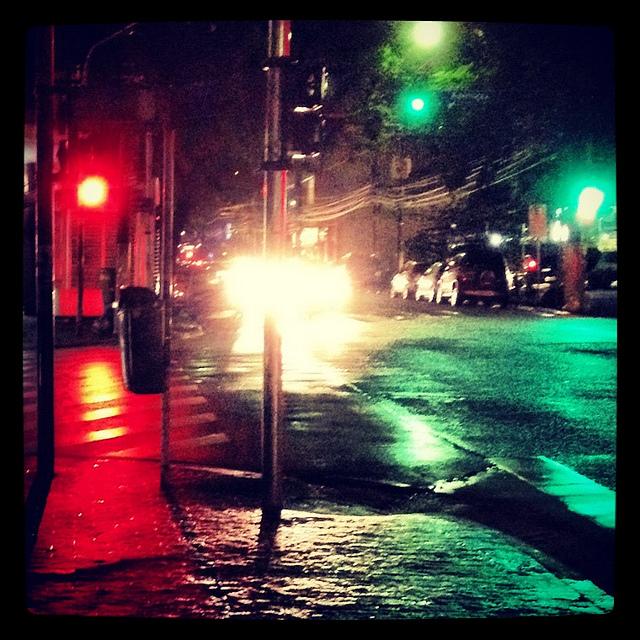Has it rained the streets are wet?
Keep it brief. Yes. Why are the lights blurry?
Be succinct. Rain. Are the streets wet?
Concise answer only. Yes. 